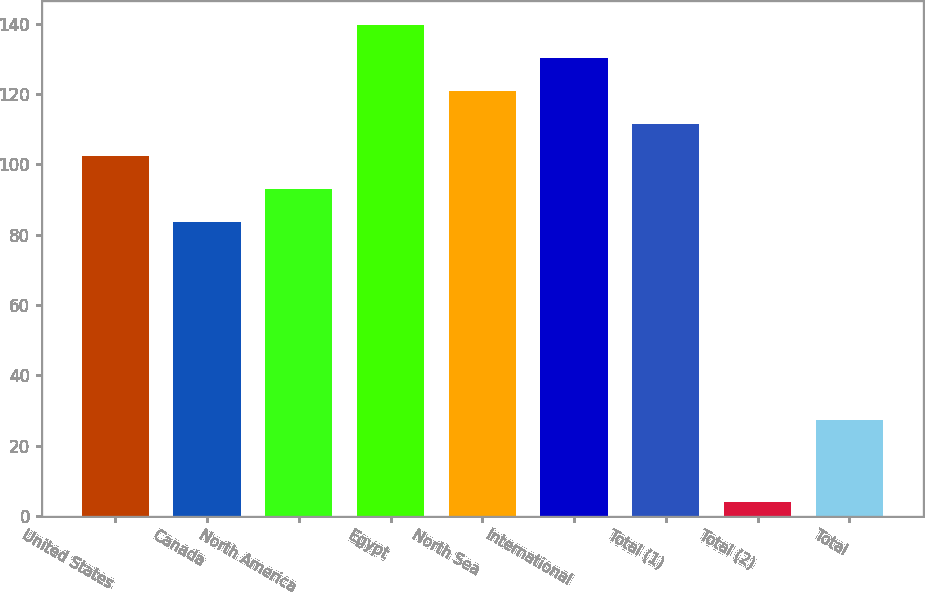Convert chart to OTSL. <chart><loc_0><loc_0><loc_500><loc_500><bar_chart><fcel>United States<fcel>Canada<fcel>North America<fcel>Egypt<fcel>North Sea<fcel>International<fcel>Total (1)<fcel>Total (2)<fcel>Total<nl><fcel>102.25<fcel>83.57<fcel>92.91<fcel>139.61<fcel>120.93<fcel>130.27<fcel>111.59<fcel>4.05<fcel>27.28<nl></chart> 